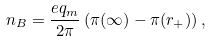Convert formula to latex. <formula><loc_0><loc_0><loc_500><loc_500>n _ { B } = \frac { e q _ { m } } { 2 \pi } \left ( \pi ( \infty ) - \pi ( r _ { + } ) \right ) ,</formula> 